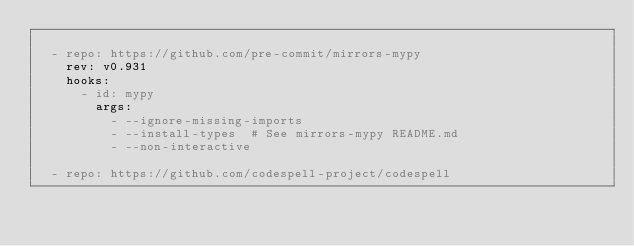<code> <loc_0><loc_0><loc_500><loc_500><_YAML_>
  - repo: https://github.com/pre-commit/mirrors-mypy
    rev: v0.931
    hooks:
      - id: mypy
        args:
          - --ignore-missing-imports
          - --install-types  # See mirrors-mypy README.md
          - --non-interactive

  - repo: https://github.com/codespell-project/codespell</code> 